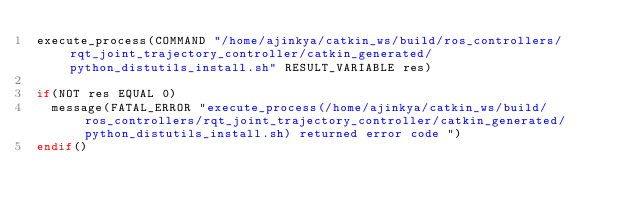<code> <loc_0><loc_0><loc_500><loc_500><_CMake_>execute_process(COMMAND "/home/ajinkya/catkin_ws/build/ros_controllers/rqt_joint_trajectory_controller/catkin_generated/python_distutils_install.sh" RESULT_VARIABLE res)

if(NOT res EQUAL 0)
  message(FATAL_ERROR "execute_process(/home/ajinkya/catkin_ws/build/ros_controllers/rqt_joint_trajectory_controller/catkin_generated/python_distutils_install.sh) returned error code ")
endif()
</code> 